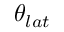Convert formula to latex. <formula><loc_0><loc_0><loc_500><loc_500>\theta _ { l a t }</formula> 